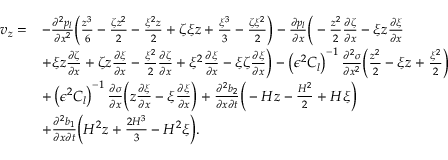Convert formula to latex. <formula><loc_0><loc_0><loc_500><loc_500>\begin{array} { r l } { v _ { z } = } & { - \frac { \partial ^ { 2 } p _ { l } } { \partial x ^ { 2 } } \left ( \frac { z ^ { 3 } } { 6 } - \frac { \zeta z ^ { 2 } } { 2 } - \frac { \xi ^ { 2 } z } { 2 } + \zeta \xi z + \frac { \xi ^ { 3 } } { 3 } - \frac { \zeta \xi ^ { 2 } } { 2 } \right ) - \frac { \partial p _ { l } } { \partial x } \left ( - \frac { z ^ { 2 } } { 2 } \frac { \partial \zeta } { \partial x } - \xi z \frac { \partial \xi } { \partial x } } \\ & { + \xi z \frac { \partial \zeta } { \partial x } + \zeta z \frac { \partial \xi } { \partial x } - \frac { \xi ^ { 2 } } { 2 } \frac { \partial \zeta } { \partial x } + \xi ^ { 2 } \frac { \partial \xi } { \partial x } - \xi \zeta \frac { \partial \xi } { \partial x } \right ) - \left ( \epsilon ^ { 2 } C _ { l } \right ) ^ { - 1 } \frac { \partial ^ { 2 } \sigma } { \partial x ^ { 2 } } \left ( \frac { z ^ { 2 } } { 2 } - \xi z + \frac { \xi ^ { 2 } } { 2 } \right ) } \\ & { + \left ( \epsilon ^ { 2 } C _ { l } \right ) ^ { - 1 } \frac { \partial \sigma } { \partial x } \left ( z \frac { \partial \xi } { \partial x } - \xi \frac { \partial \xi } { \partial x } \right ) + \frac { \partial ^ { 2 } b _ { 2 } } { \partial x \partial t } \left ( - H z - \frac { H ^ { 2 } } { 2 } + H \xi \right ) } \\ & { + \frac { \partial ^ { 2 } b _ { 1 } } { \partial x \partial t } \left ( H ^ { 2 } z + \frac { 2 H ^ { 3 } } { 3 } - H ^ { 2 } \xi \right ) . } \end{array}</formula> 